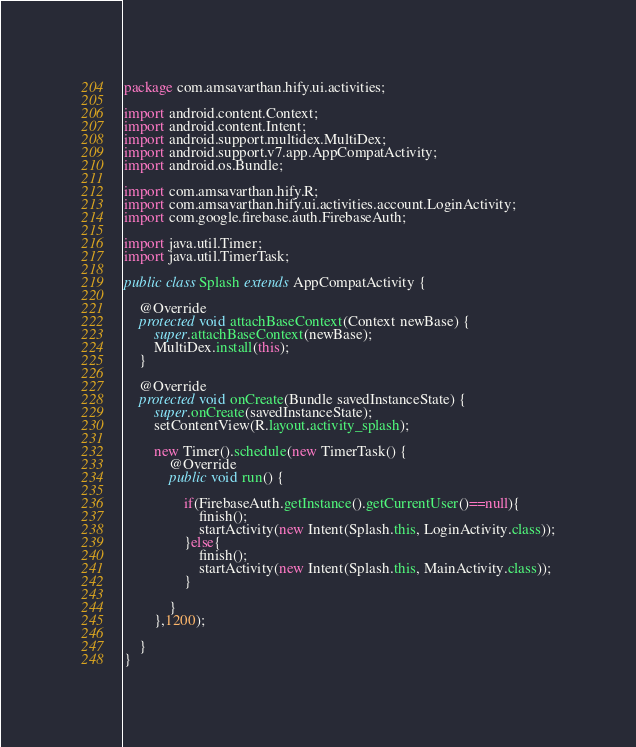<code> <loc_0><loc_0><loc_500><loc_500><_Java_>package com.amsavarthan.hify.ui.activities;

import android.content.Context;
import android.content.Intent;
import android.support.multidex.MultiDex;
import android.support.v7.app.AppCompatActivity;
import android.os.Bundle;

import com.amsavarthan.hify.R;
import com.amsavarthan.hify.ui.activities.account.LoginActivity;
import com.google.firebase.auth.FirebaseAuth;

import java.util.Timer;
import java.util.TimerTask;

public class Splash extends AppCompatActivity {

    @Override
    protected void attachBaseContext(Context newBase) {
        super.attachBaseContext(newBase);
        MultiDex.install(this);
    }

    @Override
    protected void onCreate(Bundle savedInstanceState) {
        super.onCreate(savedInstanceState);
        setContentView(R.layout.activity_splash);

        new Timer().schedule(new TimerTask() {
            @Override
            public void run() {

                if(FirebaseAuth.getInstance().getCurrentUser()==null){
                    finish();
                    startActivity(new Intent(Splash.this, LoginActivity.class));
                }else{
                    finish();
                    startActivity(new Intent(Splash.this, MainActivity.class));
                }

            }
        },1200);

    }
}
</code> 